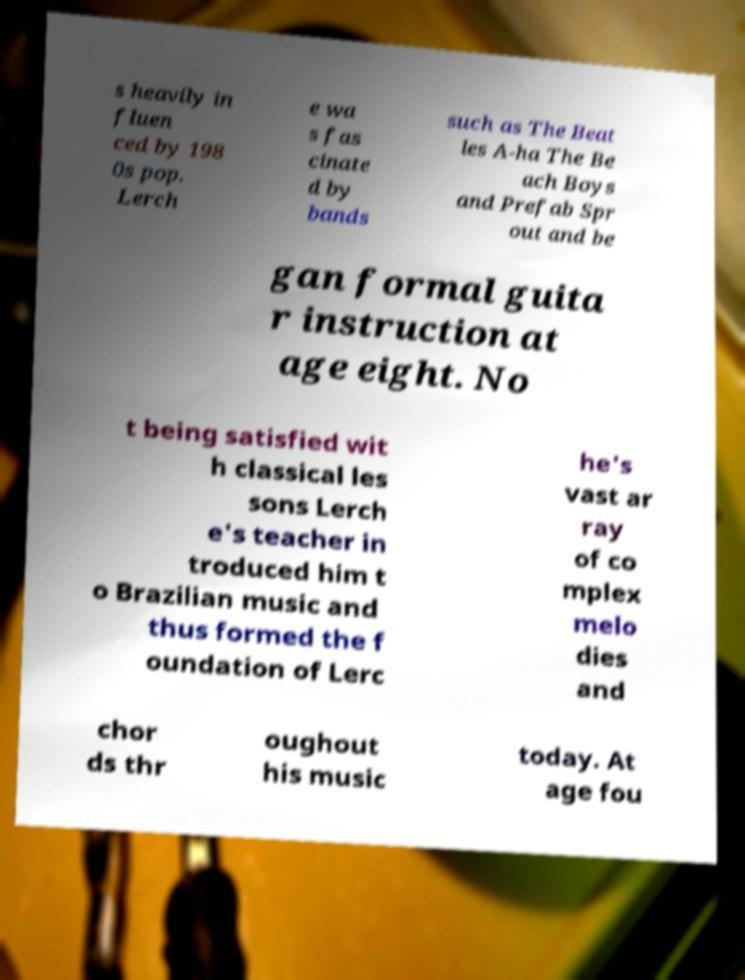Could you assist in decoding the text presented in this image and type it out clearly? s heavily in fluen ced by 198 0s pop. Lerch e wa s fas cinate d by bands such as The Beat les A-ha The Be ach Boys and Prefab Spr out and be gan formal guita r instruction at age eight. No t being satisfied wit h classical les sons Lerch e's teacher in troduced him t o Brazilian music and thus formed the f oundation of Lerc he's vast ar ray of co mplex melo dies and chor ds thr oughout his music today. At age fou 